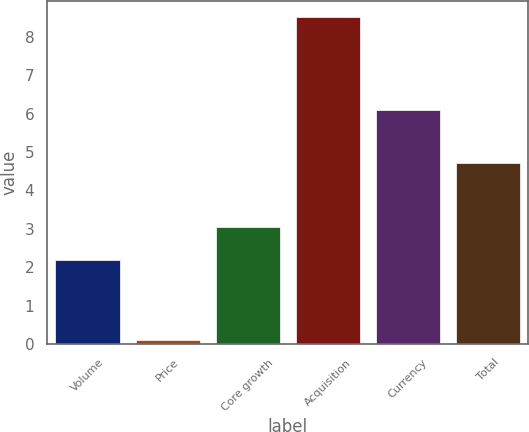Convert chart. <chart><loc_0><loc_0><loc_500><loc_500><bar_chart><fcel>Volume<fcel>Price<fcel>Core growth<fcel>Acquisition<fcel>Currency<fcel>Total<nl><fcel>2.2<fcel>0.1<fcel>3.04<fcel>8.5<fcel>6.1<fcel>4.7<nl></chart> 